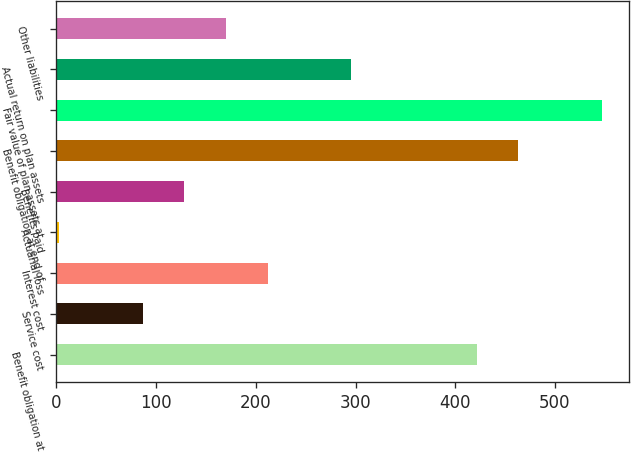Convert chart to OTSL. <chart><loc_0><loc_0><loc_500><loc_500><bar_chart><fcel>Benefit obligation at<fcel>Service cost<fcel>Interest cost<fcel>Actuarial loss<fcel>Benefits paid<fcel>Benefit obligation at end of<fcel>Fair value of plan assets at<fcel>Actual return on plan assets<fcel>Other liabilities<nl><fcel>421.5<fcel>86.54<fcel>212.15<fcel>2.8<fcel>128.41<fcel>463.37<fcel>547.11<fcel>295.89<fcel>170.28<nl></chart> 